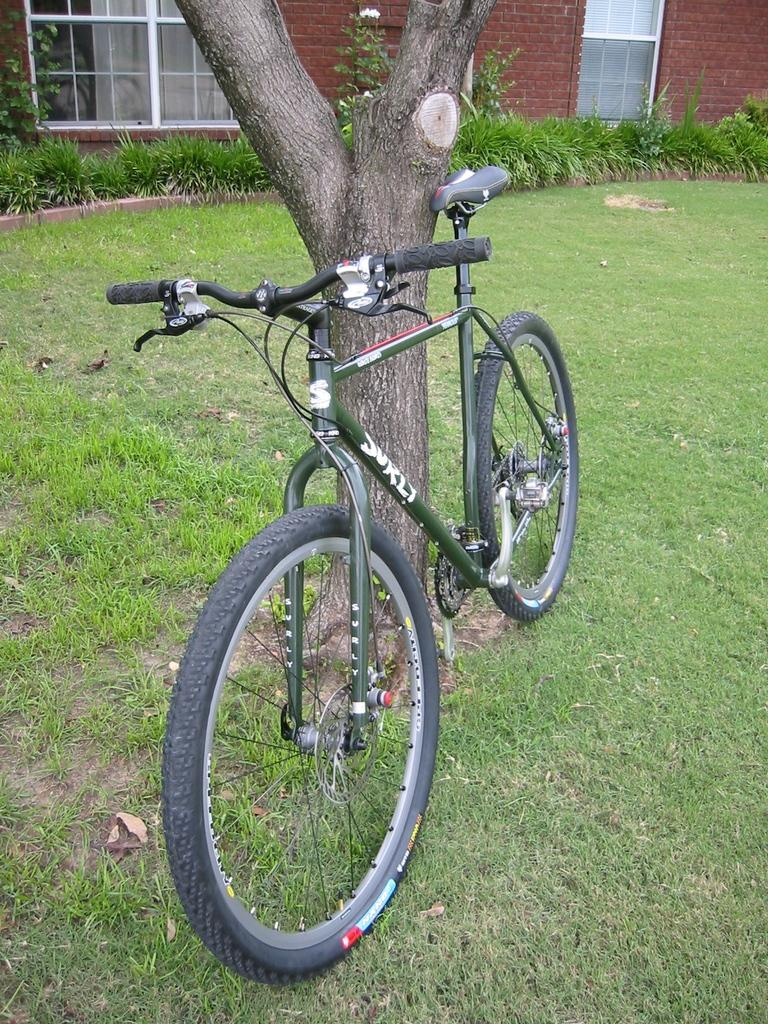What type of vegetation is present in the image? There is grass in the image. What part of a tree can be seen in the image? There is a tree stem in the image. What mode of transportation is visible in the image? There is a bicycle in the image. What type of structure can be seen in the background of the image? There is a building in the background of the image. What type of cap is worn by the tree in the image? There is no cap present in the image, as trees do not wear caps. How does the grass slip on the surface in the image? The grass does not slip on the surface in the image; it is stationary vegetation. 